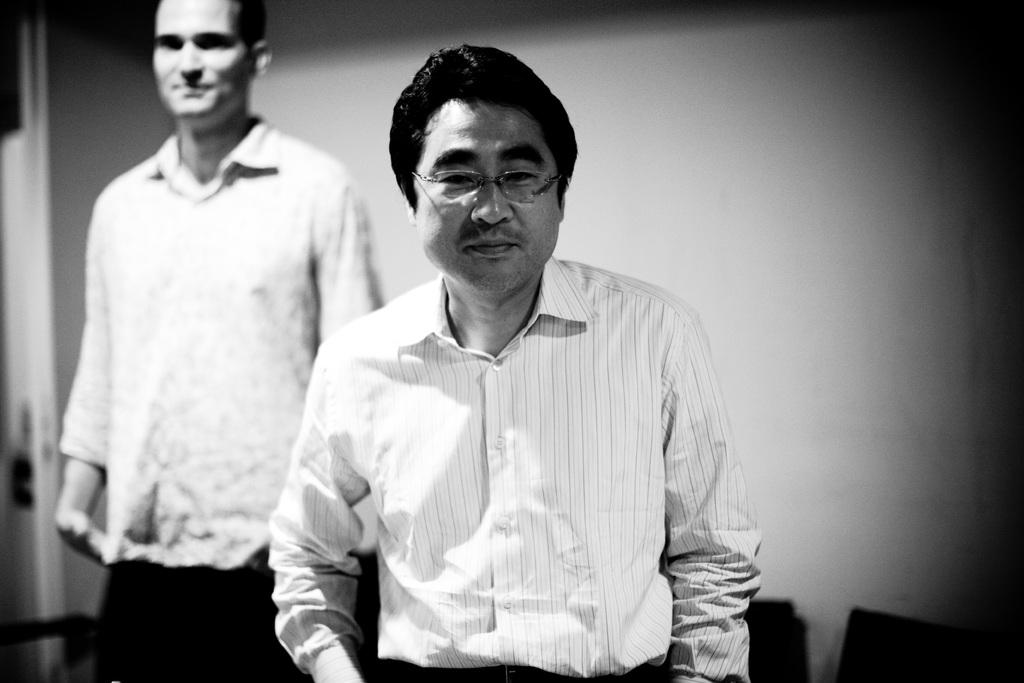How many people are in the image? There are two men in the image. Can you describe one of the men's appearance? One of the men is wearing spectacles. What is visible in the background of the image? There is a wall and objects visible in the background of the image. What type of hat is the man wearing in the image? There is no hat visible in the image; one of the men is wearing spectacles. What liquid can be seen flowing from the wall in the image? There is no liquid flowing from the wall in the image; only a wall and objects are visible in the background. 